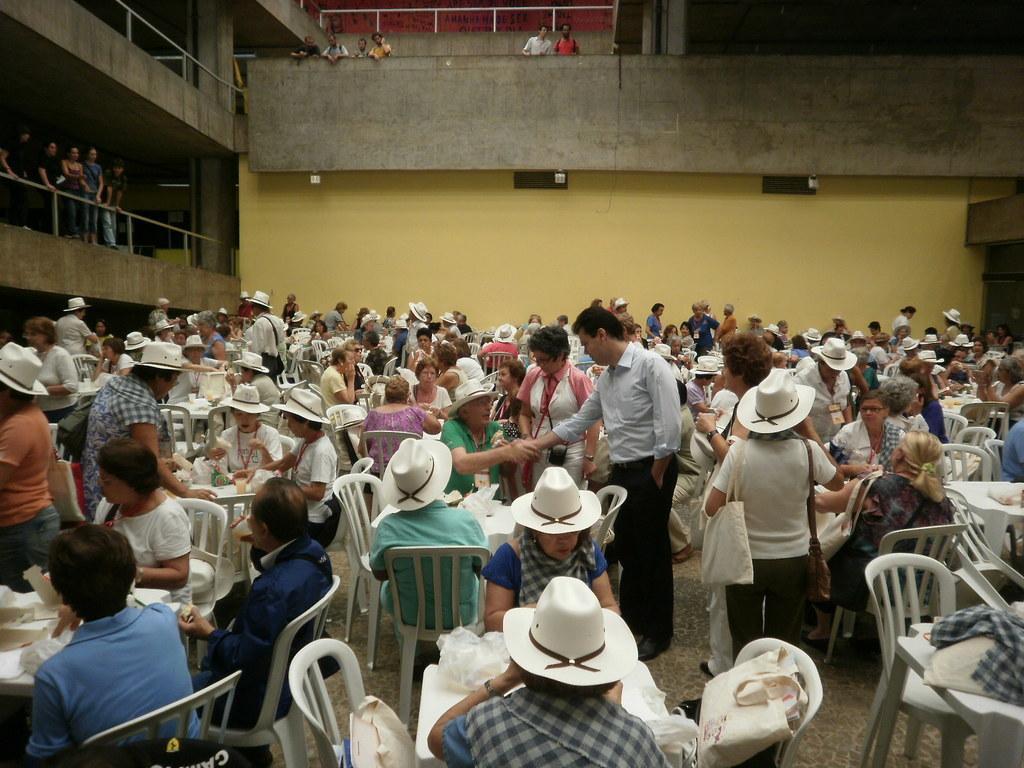Please provide a concise description of this image. In this picture there are many people sitting in the chairs in front their respective tables and eating the food which is on the table. Some of them were hats. Some of them were standing. In the background, there is a wall and some people standing and watching her. 